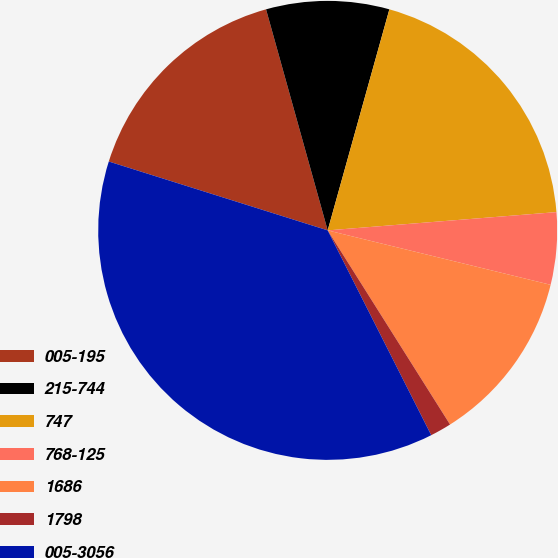Convert chart to OTSL. <chart><loc_0><loc_0><loc_500><loc_500><pie_chart><fcel>005-195<fcel>215-744<fcel>747<fcel>768-125<fcel>1686<fcel>1798<fcel>005-3056<nl><fcel>15.82%<fcel>8.66%<fcel>19.4%<fcel>5.08%<fcel>12.24%<fcel>1.5%<fcel>37.3%<nl></chart> 